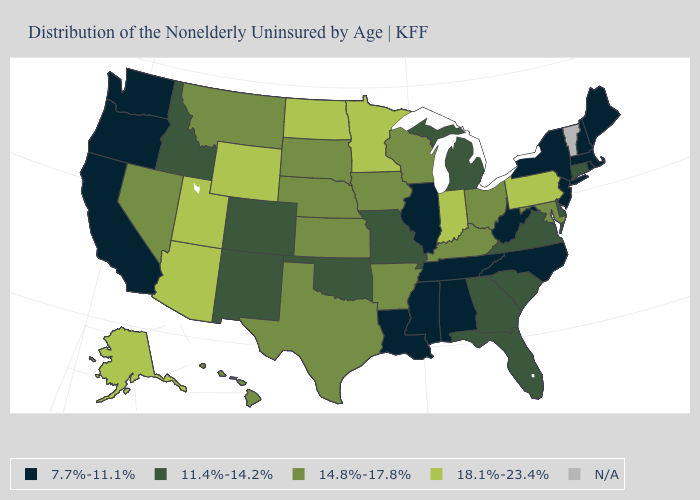What is the value of Connecticut?
Be succinct. 11.4%-14.2%. What is the highest value in the West ?
Be succinct. 18.1%-23.4%. Does the first symbol in the legend represent the smallest category?
Write a very short answer. Yes. What is the value of Maryland?
Concise answer only. 14.8%-17.8%. What is the highest value in the West ?
Be succinct. 18.1%-23.4%. Which states have the lowest value in the USA?
Be succinct. Alabama, California, Illinois, Louisiana, Maine, Massachusetts, Mississippi, New Hampshire, New Jersey, New York, North Carolina, Oregon, Rhode Island, Tennessee, Washington, West Virginia. What is the lowest value in states that border Pennsylvania?
Be succinct. 7.7%-11.1%. Which states have the lowest value in the USA?
Concise answer only. Alabama, California, Illinois, Louisiana, Maine, Massachusetts, Mississippi, New Hampshire, New Jersey, New York, North Carolina, Oregon, Rhode Island, Tennessee, Washington, West Virginia. What is the value of New York?
Be succinct. 7.7%-11.1%. What is the value of Tennessee?
Write a very short answer. 7.7%-11.1%. Which states hav the highest value in the West?
Answer briefly. Alaska, Arizona, Utah, Wyoming. Is the legend a continuous bar?
Keep it brief. No. Name the states that have a value in the range 11.4%-14.2%?
Be succinct. Colorado, Connecticut, Delaware, Florida, Georgia, Idaho, Michigan, Missouri, New Mexico, Oklahoma, South Carolina, Virginia. Does Indiana have the highest value in the MidWest?
Write a very short answer. Yes. 